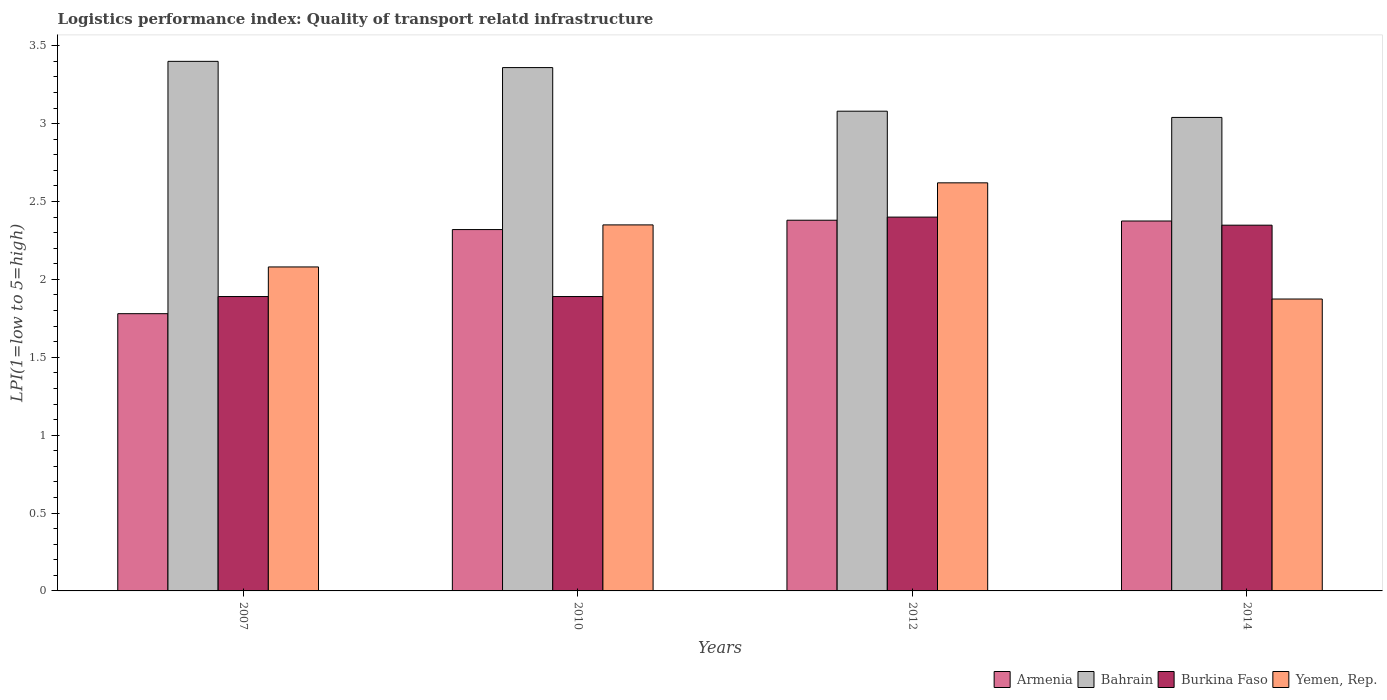How many groups of bars are there?
Make the answer very short. 4. Are the number of bars per tick equal to the number of legend labels?
Offer a terse response. Yes. Are the number of bars on each tick of the X-axis equal?
Your answer should be compact. Yes. How many bars are there on the 4th tick from the left?
Keep it short and to the point. 4. How many bars are there on the 4th tick from the right?
Your response must be concise. 4. What is the label of the 3rd group of bars from the left?
Provide a succinct answer. 2012. In how many cases, is the number of bars for a given year not equal to the number of legend labels?
Your answer should be very brief. 0. What is the logistics performance index in Bahrain in 2010?
Make the answer very short. 3.36. Across all years, what is the minimum logistics performance index in Yemen, Rep.?
Ensure brevity in your answer.  1.87. In which year was the logistics performance index in Burkina Faso minimum?
Make the answer very short. 2007. What is the total logistics performance index in Armenia in the graph?
Keep it short and to the point. 8.86. What is the difference between the logistics performance index in Yemen, Rep. in 2010 and that in 2012?
Provide a short and direct response. -0.27. What is the difference between the logistics performance index in Armenia in 2007 and the logistics performance index in Burkina Faso in 2010?
Offer a terse response. -0.11. What is the average logistics performance index in Burkina Faso per year?
Your response must be concise. 2.13. In the year 2012, what is the difference between the logistics performance index in Bahrain and logistics performance index in Burkina Faso?
Keep it short and to the point. 0.68. In how many years, is the logistics performance index in Burkina Faso greater than 2?
Provide a short and direct response. 2. What is the ratio of the logistics performance index in Bahrain in 2007 to that in 2014?
Your answer should be compact. 1.12. Is the logistics performance index in Bahrain in 2012 less than that in 2014?
Give a very brief answer. No. What is the difference between the highest and the second highest logistics performance index in Bahrain?
Make the answer very short. 0.04. What is the difference between the highest and the lowest logistics performance index in Yemen, Rep.?
Give a very brief answer. 0.75. Is it the case that in every year, the sum of the logistics performance index in Burkina Faso and logistics performance index in Bahrain is greater than the sum of logistics performance index in Yemen, Rep. and logistics performance index in Armenia?
Offer a very short reply. Yes. What does the 1st bar from the left in 2007 represents?
Offer a very short reply. Armenia. What does the 4th bar from the right in 2014 represents?
Make the answer very short. Armenia. Is it the case that in every year, the sum of the logistics performance index in Burkina Faso and logistics performance index in Bahrain is greater than the logistics performance index in Armenia?
Your answer should be very brief. Yes. How many bars are there?
Your answer should be compact. 16. Are all the bars in the graph horizontal?
Offer a very short reply. No. How many years are there in the graph?
Offer a terse response. 4. Are the values on the major ticks of Y-axis written in scientific E-notation?
Offer a very short reply. No. Does the graph contain any zero values?
Give a very brief answer. No. What is the title of the graph?
Your answer should be compact. Logistics performance index: Quality of transport relatd infrastructure. What is the label or title of the X-axis?
Make the answer very short. Years. What is the label or title of the Y-axis?
Your answer should be compact. LPI(1=low to 5=high). What is the LPI(1=low to 5=high) of Armenia in 2007?
Make the answer very short. 1.78. What is the LPI(1=low to 5=high) of Burkina Faso in 2007?
Offer a terse response. 1.89. What is the LPI(1=low to 5=high) of Yemen, Rep. in 2007?
Provide a short and direct response. 2.08. What is the LPI(1=low to 5=high) in Armenia in 2010?
Ensure brevity in your answer.  2.32. What is the LPI(1=low to 5=high) of Bahrain in 2010?
Offer a terse response. 3.36. What is the LPI(1=low to 5=high) of Burkina Faso in 2010?
Ensure brevity in your answer.  1.89. What is the LPI(1=low to 5=high) in Yemen, Rep. in 2010?
Offer a terse response. 2.35. What is the LPI(1=low to 5=high) in Armenia in 2012?
Your answer should be very brief. 2.38. What is the LPI(1=low to 5=high) in Bahrain in 2012?
Keep it short and to the point. 3.08. What is the LPI(1=low to 5=high) in Yemen, Rep. in 2012?
Offer a very short reply. 2.62. What is the LPI(1=low to 5=high) of Armenia in 2014?
Give a very brief answer. 2.38. What is the LPI(1=low to 5=high) of Bahrain in 2014?
Your answer should be very brief. 3.04. What is the LPI(1=low to 5=high) in Burkina Faso in 2014?
Ensure brevity in your answer.  2.35. What is the LPI(1=low to 5=high) in Yemen, Rep. in 2014?
Your answer should be compact. 1.87. Across all years, what is the maximum LPI(1=low to 5=high) of Armenia?
Your answer should be very brief. 2.38. Across all years, what is the maximum LPI(1=low to 5=high) in Bahrain?
Offer a very short reply. 3.4. Across all years, what is the maximum LPI(1=low to 5=high) in Burkina Faso?
Offer a terse response. 2.4. Across all years, what is the maximum LPI(1=low to 5=high) in Yemen, Rep.?
Offer a very short reply. 2.62. Across all years, what is the minimum LPI(1=low to 5=high) of Armenia?
Give a very brief answer. 1.78. Across all years, what is the minimum LPI(1=low to 5=high) of Bahrain?
Your response must be concise. 3.04. Across all years, what is the minimum LPI(1=low to 5=high) of Burkina Faso?
Provide a short and direct response. 1.89. Across all years, what is the minimum LPI(1=low to 5=high) in Yemen, Rep.?
Give a very brief answer. 1.87. What is the total LPI(1=low to 5=high) in Armenia in the graph?
Provide a short and direct response. 8.86. What is the total LPI(1=low to 5=high) of Bahrain in the graph?
Provide a short and direct response. 12.88. What is the total LPI(1=low to 5=high) of Burkina Faso in the graph?
Offer a terse response. 8.53. What is the total LPI(1=low to 5=high) in Yemen, Rep. in the graph?
Give a very brief answer. 8.92. What is the difference between the LPI(1=low to 5=high) in Armenia in 2007 and that in 2010?
Offer a terse response. -0.54. What is the difference between the LPI(1=low to 5=high) of Yemen, Rep. in 2007 and that in 2010?
Keep it short and to the point. -0.27. What is the difference between the LPI(1=low to 5=high) in Armenia in 2007 and that in 2012?
Provide a succinct answer. -0.6. What is the difference between the LPI(1=low to 5=high) in Bahrain in 2007 and that in 2012?
Offer a very short reply. 0.32. What is the difference between the LPI(1=low to 5=high) of Burkina Faso in 2007 and that in 2012?
Keep it short and to the point. -0.51. What is the difference between the LPI(1=low to 5=high) of Yemen, Rep. in 2007 and that in 2012?
Give a very brief answer. -0.54. What is the difference between the LPI(1=low to 5=high) of Armenia in 2007 and that in 2014?
Your answer should be compact. -0.59. What is the difference between the LPI(1=low to 5=high) of Bahrain in 2007 and that in 2014?
Your answer should be very brief. 0.36. What is the difference between the LPI(1=low to 5=high) of Burkina Faso in 2007 and that in 2014?
Provide a short and direct response. -0.46. What is the difference between the LPI(1=low to 5=high) of Yemen, Rep. in 2007 and that in 2014?
Make the answer very short. 0.21. What is the difference between the LPI(1=low to 5=high) of Armenia in 2010 and that in 2012?
Your response must be concise. -0.06. What is the difference between the LPI(1=low to 5=high) in Bahrain in 2010 and that in 2012?
Make the answer very short. 0.28. What is the difference between the LPI(1=low to 5=high) in Burkina Faso in 2010 and that in 2012?
Provide a short and direct response. -0.51. What is the difference between the LPI(1=low to 5=high) in Yemen, Rep. in 2010 and that in 2012?
Your answer should be very brief. -0.27. What is the difference between the LPI(1=low to 5=high) in Armenia in 2010 and that in 2014?
Make the answer very short. -0.06. What is the difference between the LPI(1=low to 5=high) in Bahrain in 2010 and that in 2014?
Your answer should be very brief. 0.32. What is the difference between the LPI(1=low to 5=high) in Burkina Faso in 2010 and that in 2014?
Your answer should be very brief. -0.46. What is the difference between the LPI(1=low to 5=high) in Yemen, Rep. in 2010 and that in 2014?
Ensure brevity in your answer.  0.48. What is the difference between the LPI(1=low to 5=high) in Armenia in 2012 and that in 2014?
Offer a terse response. 0.01. What is the difference between the LPI(1=low to 5=high) of Bahrain in 2012 and that in 2014?
Ensure brevity in your answer.  0.04. What is the difference between the LPI(1=low to 5=high) of Burkina Faso in 2012 and that in 2014?
Provide a short and direct response. 0.05. What is the difference between the LPI(1=low to 5=high) in Yemen, Rep. in 2012 and that in 2014?
Make the answer very short. 0.75. What is the difference between the LPI(1=low to 5=high) in Armenia in 2007 and the LPI(1=low to 5=high) in Bahrain in 2010?
Ensure brevity in your answer.  -1.58. What is the difference between the LPI(1=low to 5=high) of Armenia in 2007 and the LPI(1=low to 5=high) of Burkina Faso in 2010?
Your response must be concise. -0.11. What is the difference between the LPI(1=low to 5=high) of Armenia in 2007 and the LPI(1=low to 5=high) of Yemen, Rep. in 2010?
Your answer should be compact. -0.57. What is the difference between the LPI(1=low to 5=high) of Bahrain in 2007 and the LPI(1=low to 5=high) of Burkina Faso in 2010?
Your answer should be compact. 1.51. What is the difference between the LPI(1=low to 5=high) in Bahrain in 2007 and the LPI(1=low to 5=high) in Yemen, Rep. in 2010?
Give a very brief answer. 1.05. What is the difference between the LPI(1=low to 5=high) of Burkina Faso in 2007 and the LPI(1=low to 5=high) of Yemen, Rep. in 2010?
Offer a terse response. -0.46. What is the difference between the LPI(1=low to 5=high) in Armenia in 2007 and the LPI(1=low to 5=high) in Bahrain in 2012?
Ensure brevity in your answer.  -1.3. What is the difference between the LPI(1=low to 5=high) in Armenia in 2007 and the LPI(1=low to 5=high) in Burkina Faso in 2012?
Provide a short and direct response. -0.62. What is the difference between the LPI(1=low to 5=high) in Armenia in 2007 and the LPI(1=low to 5=high) in Yemen, Rep. in 2012?
Provide a short and direct response. -0.84. What is the difference between the LPI(1=low to 5=high) in Bahrain in 2007 and the LPI(1=low to 5=high) in Burkina Faso in 2012?
Give a very brief answer. 1. What is the difference between the LPI(1=low to 5=high) of Bahrain in 2007 and the LPI(1=low to 5=high) of Yemen, Rep. in 2012?
Offer a terse response. 0.78. What is the difference between the LPI(1=low to 5=high) in Burkina Faso in 2007 and the LPI(1=low to 5=high) in Yemen, Rep. in 2012?
Offer a very short reply. -0.73. What is the difference between the LPI(1=low to 5=high) of Armenia in 2007 and the LPI(1=low to 5=high) of Bahrain in 2014?
Provide a succinct answer. -1.26. What is the difference between the LPI(1=low to 5=high) of Armenia in 2007 and the LPI(1=low to 5=high) of Burkina Faso in 2014?
Your response must be concise. -0.57. What is the difference between the LPI(1=low to 5=high) of Armenia in 2007 and the LPI(1=low to 5=high) of Yemen, Rep. in 2014?
Keep it short and to the point. -0.09. What is the difference between the LPI(1=low to 5=high) in Bahrain in 2007 and the LPI(1=low to 5=high) in Burkina Faso in 2014?
Provide a succinct answer. 1.05. What is the difference between the LPI(1=low to 5=high) in Bahrain in 2007 and the LPI(1=low to 5=high) in Yemen, Rep. in 2014?
Ensure brevity in your answer.  1.53. What is the difference between the LPI(1=low to 5=high) in Burkina Faso in 2007 and the LPI(1=low to 5=high) in Yemen, Rep. in 2014?
Your response must be concise. 0.02. What is the difference between the LPI(1=low to 5=high) in Armenia in 2010 and the LPI(1=low to 5=high) in Bahrain in 2012?
Offer a very short reply. -0.76. What is the difference between the LPI(1=low to 5=high) of Armenia in 2010 and the LPI(1=low to 5=high) of Burkina Faso in 2012?
Your answer should be very brief. -0.08. What is the difference between the LPI(1=low to 5=high) in Bahrain in 2010 and the LPI(1=low to 5=high) in Burkina Faso in 2012?
Ensure brevity in your answer.  0.96. What is the difference between the LPI(1=low to 5=high) of Bahrain in 2010 and the LPI(1=low to 5=high) of Yemen, Rep. in 2012?
Give a very brief answer. 0.74. What is the difference between the LPI(1=low to 5=high) of Burkina Faso in 2010 and the LPI(1=low to 5=high) of Yemen, Rep. in 2012?
Provide a succinct answer. -0.73. What is the difference between the LPI(1=low to 5=high) of Armenia in 2010 and the LPI(1=low to 5=high) of Bahrain in 2014?
Provide a short and direct response. -0.72. What is the difference between the LPI(1=low to 5=high) of Armenia in 2010 and the LPI(1=low to 5=high) of Burkina Faso in 2014?
Your response must be concise. -0.03. What is the difference between the LPI(1=low to 5=high) in Armenia in 2010 and the LPI(1=low to 5=high) in Yemen, Rep. in 2014?
Your answer should be compact. 0.45. What is the difference between the LPI(1=low to 5=high) of Bahrain in 2010 and the LPI(1=low to 5=high) of Burkina Faso in 2014?
Your answer should be very brief. 1.01. What is the difference between the LPI(1=low to 5=high) of Bahrain in 2010 and the LPI(1=low to 5=high) of Yemen, Rep. in 2014?
Provide a short and direct response. 1.49. What is the difference between the LPI(1=low to 5=high) in Burkina Faso in 2010 and the LPI(1=low to 5=high) in Yemen, Rep. in 2014?
Your answer should be very brief. 0.02. What is the difference between the LPI(1=low to 5=high) in Armenia in 2012 and the LPI(1=low to 5=high) in Bahrain in 2014?
Keep it short and to the point. -0.66. What is the difference between the LPI(1=low to 5=high) in Armenia in 2012 and the LPI(1=low to 5=high) in Burkina Faso in 2014?
Offer a very short reply. 0.03. What is the difference between the LPI(1=low to 5=high) of Armenia in 2012 and the LPI(1=low to 5=high) of Yemen, Rep. in 2014?
Offer a terse response. 0.51. What is the difference between the LPI(1=low to 5=high) in Bahrain in 2012 and the LPI(1=low to 5=high) in Burkina Faso in 2014?
Your answer should be very brief. 0.73. What is the difference between the LPI(1=low to 5=high) of Bahrain in 2012 and the LPI(1=low to 5=high) of Yemen, Rep. in 2014?
Your answer should be compact. 1.21. What is the difference between the LPI(1=low to 5=high) of Burkina Faso in 2012 and the LPI(1=low to 5=high) of Yemen, Rep. in 2014?
Offer a very short reply. 0.53. What is the average LPI(1=low to 5=high) of Armenia per year?
Make the answer very short. 2.21. What is the average LPI(1=low to 5=high) of Bahrain per year?
Keep it short and to the point. 3.22. What is the average LPI(1=low to 5=high) of Burkina Faso per year?
Your answer should be very brief. 2.13. What is the average LPI(1=low to 5=high) of Yemen, Rep. per year?
Give a very brief answer. 2.23. In the year 2007, what is the difference between the LPI(1=low to 5=high) of Armenia and LPI(1=low to 5=high) of Bahrain?
Your answer should be compact. -1.62. In the year 2007, what is the difference between the LPI(1=low to 5=high) of Armenia and LPI(1=low to 5=high) of Burkina Faso?
Your response must be concise. -0.11. In the year 2007, what is the difference between the LPI(1=low to 5=high) of Bahrain and LPI(1=low to 5=high) of Burkina Faso?
Provide a short and direct response. 1.51. In the year 2007, what is the difference between the LPI(1=low to 5=high) in Bahrain and LPI(1=low to 5=high) in Yemen, Rep.?
Make the answer very short. 1.32. In the year 2007, what is the difference between the LPI(1=low to 5=high) of Burkina Faso and LPI(1=low to 5=high) of Yemen, Rep.?
Provide a succinct answer. -0.19. In the year 2010, what is the difference between the LPI(1=low to 5=high) in Armenia and LPI(1=low to 5=high) in Bahrain?
Provide a succinct answer. -1.04. In the year 2010, what is the difference between the LPI(1=low to 5=high) in Armenia and LPI(1=low to 5=high) in Burkina Faso?
Make the answer very short. 0.43. In the year 2010, what is the difference between the LPI(1=low to 5=high) in Armenia and LPI(1=low to 5=high) in Yemen, Rep.?
Offer a very short reply. -0.03. In the year 2010, what is the difference between the LPI(1=low to 5=high) in Bahrain and LPI(1=low to 5=high) in Burkina Faso?
Your response must be concise. 1.47. In the year 2010, what is the difference between the LPI(1=low to 5=high) in Burkina Faso and LPI(1=low to 5=high) in Yemen, Rep.?
Ensure brevity in your answer.  -0.46. In the year 2012, what is the difference between the LPI(1=low to 5=high) in Armenia and LPI(1=low to 5=high) in Burkina Faso?
Offer a terse response. -0.02. In the year 2012, what is the difference between the LPI(1=low to 5=high) of Armenia and LPI(1=low to 5=high) of Yemen, Rep.?
Make the answer very short. -0.24. In the year 2012, what is the difference between the LPI(1=low to 5=high) of Bahrain and LPI(1=low to 5=high) of Burkina Faso?
Provide a succinct answer. 0.68. In the year 2012, what is the difference between the LPI(1=low to 5=high) in Bahrain and LPI(1=low to 5=high) in Yemen, Rep.?
Ensure brevity in your answer.  0.46. In the year 2012, what is the difference between the LPI(1=low to 5=high) of Burkina Faso and LPI(1=low to 5=high) of Yemen, Rep.?
Your answer should be compact. -0.22. In the year 2014, what is the difference between the LPI(1=low to 5=high) of Armenia and LPI(1=low to 5=high) of Bahrain?
Offer a very short reply. -0.67. In the year 2014, what is the difference between the LPI(1=low to 5=high) of Armenia and LPI(1=low to 5=high) of Burkina Faso?
Offer a very short reply. 0.03. In the year 2014, what is the difference between the LPI(1=low to 5=high) in Armenia and LPI(1=low to 5=high) in Yemen, Rep.?
Your answer should be very brief. 0.5. In the year 2014, what is the difference between the LPI(1=low to 5=high) of Bahrain and LPI(1=low to 5=high) of Burkina Faso?
Offer a very short reply. 0.69. In the year 2014, what is the difference between the LPI(1=low to 5=high) of Bahrain and LPI(1=low to 5=high) of Yemen, Rep.?
Ensure brevity in your answer.  1.17. In the year 2014, what is the difference between the LPI(1=low to 5=high) of Burkina Faso and LPI(1=low to 5=high) of Yemen, Rep.?
Ensure brevity in your answer.  0.47. What is the ratio of the LPI(1=low to 5=high) in Armenia in 2007 to that in 2010?
Keep it short and to the point. 0.77. What is the ratio of the LPI(1=low to 5=high) of Bahrain in 2007 to that in 2010?
Provide a short and direct response. 1.01. What is the ratio of the LPI(1=low to 5=high) of Yemen, Rep. in 2007 to that in 2010?
Ensure brevity in your answer.  0.89. What is the ratio of the LPI(1=low to 5=high) in Armenia in 2007 to that in 2012?
Your answer should be compact. 0.75. What is the ratio of the LPI(1=low to 5=high) of Bahrain in 2007 to that in 2012?
Offer a very short reply. 1.1. What is the ratio of the LPI(1=low to 5=high) in Burkina Faso in 2007 to that in 2012?
Your answer should be compact. 0.79. What is the ratio of the LPI(1=low to 5=high) of Yemen, Rep. in 2007 to that in 2012?
Give a very brief answer. 0.79. What is the ratio of the LPI(1=low to 5=high) in Armenia in 2007 to that in 2014?
Offer a very short reply. 0.75. What is the ratio of the LPI(1=low to 5=high) of Bahrain in 2007 to that in 2014?
Ensure brevity in your answer.  1.12. What is the ratio of the LPI(1=low to 5=high) of Burkina Faso in 2007 to that in 2014?
Keep it short and to the point. 0.8. What is the ratio of the LPI(1=low to 5=high) of Yemen, Rep. in 2007 to that in 2014?
Your response must be concise. 1.11. What is the ratio of the LPI(1=low to 5=high) of Armenia in 2010 to that in 2012?
Your response must be concise. 0.97. What is the ratio of the LPI(1=low to 5=high) in Burkina Faso in 2010 to that in 2012?
Offer a terse response. 0.79. What is the ratio of the LPI(1=low to 5=high) of Yemen, Rep. in 2010 to that in 2012?
Keep it short and to the point. 0.9. What is the ratio of the LPI(1=low to 5=high) of Armenia in 2010 to that in 2014?
Give a very brief answer. 0.98. What is the ratio of the LPI(1=low to 5=high) in Bahrain in 2010 to that in 2014?
Give a very brief answer. 1.11. What is the ratio of the LPI(1=low to 5=high) of Burkina Faso in 2010 to that in 2014?
Make the answer very short. 0.8. What is the ratio of the LPI(1=low to 5=high) in Yemen, Rep. in 2010 to that in 2014?
Your answer should be very brief. 1.25. What is the ratio of the LPI(1=low to 5=high) of Armenia in 2012 to that in 2014?
Provide a short and direct response. 1. What is the ratio of the LPI(1=low to 5=high) in Bahrain in 2012 to that in 2014?
Keep it short and to the point. 1.01. What is the ratio of the LPI(1=low to 5=high) in Burkina Faso in 2012 to that in 2014?
Your response must be concise. 1.02. What is the ratio of the LPI(1=low to 5=high) of Yemen, Rep. in 2012 to that in 2014?
Ensure brevity in your answer.  1.4. What is the difference between the highest and the second highest LPI(1=low to 5=high) in Armenia?
Your answer should be very brief. 0.01. What is the difference between the highest and the second highest LPI(1=low to 5=high) in Burkina Faso?
Provide a short and direct response. 0.05. What is the difference between the highest and the second highest LPI(1=low to 5=high) in Yemen, Rep.?
Offer a very short reply. 0.27. What is the difference between the highest and the lowest LPI(1=low to 5=high) of Armenia?
Ensure brevity in your answer.  0.6. What is the difference between the highest and the lowest LPI(1=low to 5=high) in Bahrain?
Keep it short and to the point. 0.36. What is the difference between the highest and the lowest LPI(1=low to 5=high) in Burkina Faso?
Offer a very short reply. 0.51. What is the difference between the highest and the lowest LPI(1=low to 5=high) of Yemen, Rep.?
Make the answer very short. 0.75. 